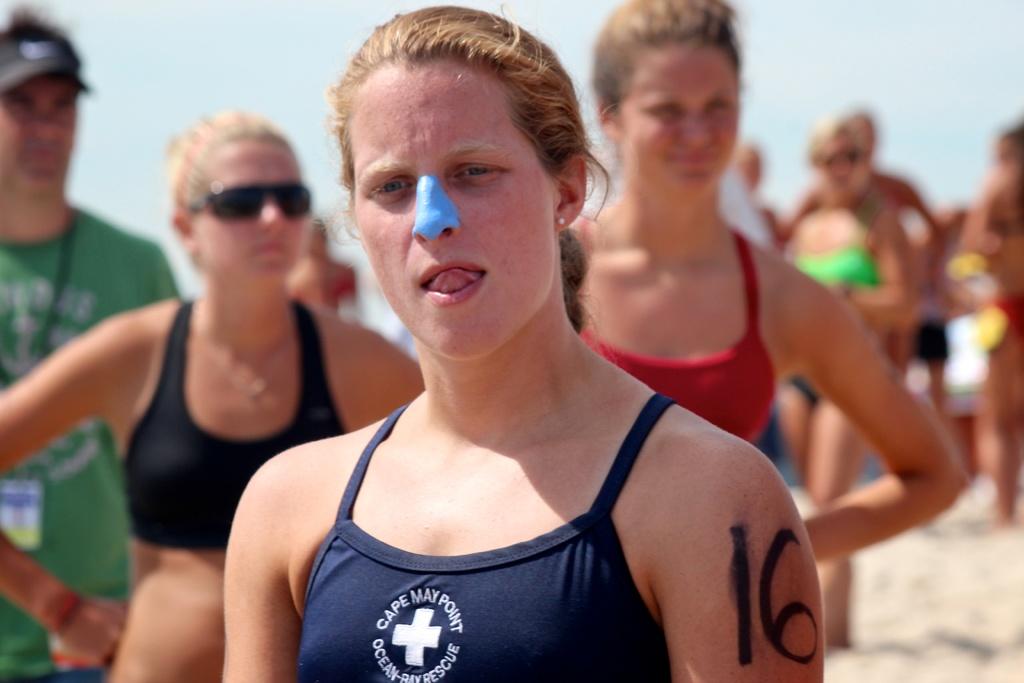What number is written on the person's arm?
Provide a succinct answer. 16. What does it say on the girl's bathing suit?
Your answer should be very brief. Cape may point ocean rescue. 